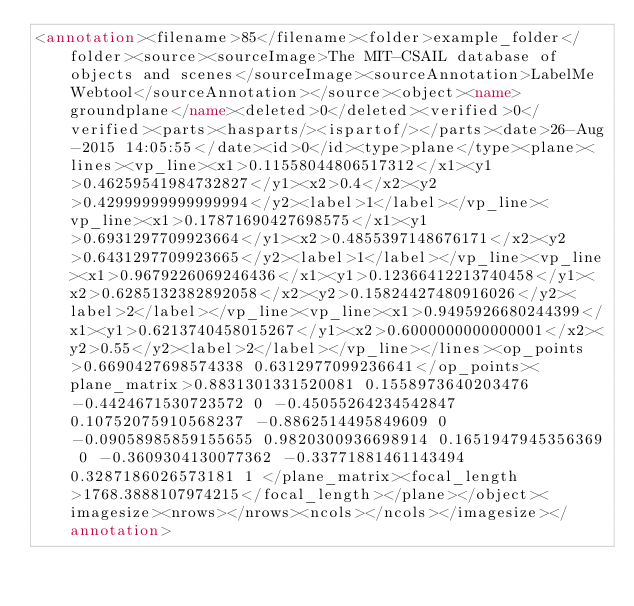<code> <loc_0><loc_0><loc_500><loc_500><_XML_><annotation><filename>85</filename><folder>example_folder</folder><source><sourceImage>The MIT-CSAIL database of objects and scenes</sourceImage><sourceAnnotation>LabelMe Webtool</sourceAnnotation></source><object><name>groundplane</name><deleted>0</deleted><verified>0</verified><parts><hasparts/><ispartof/></parts><date>26-Aug-2015 14:05:55</date><id>0</id><type>plane</type><plane><lines><vp_line><x1>0.11558044806517312</x1><y1>0.46259541984732827</y1><x2>0.4</x2><y2>0.42999999999999994</y2><label>1</label></vp_line><vp_line><x1>0.17871690427698575</x1><y1>0.6931297709923664</y1><x2>0.4855397148676171</x2><y2>0.6431297709923665</y2><label>1</label></vp_line><vp_line><x1>0.9679226069246436</x1><y1>0.12366412213740458</y1><x2>0.6285132382892058</x2><y2>0.15824427480916026</y2><label>2</label></vp_line><vp_line><x1>0.9495926680244399</x1><y1>0.6213740458015267</y1><x2>0.6000000000000001</x2><y2>0.55</y2><label>2</label></vp_line></lines><op_points>0.6690427698574338 0.6312977099236641</op_points><plane_matrix>0.8831301331520081 0.1558973640203476 -0.4424671530723572 0 -0.45055264234542847 0.10752075910568237 -0.8862514495849609 0 -0.09058985859155655 0.9820300936698914 0.1651947945356369 0 -0.3609304130077362 -0.33771881461143494 0.3287186026573181 1 </plane_matrix><focal_length>1768.3888107974215</focal_length></plane></object><imagesize><nrows></nrows><ncols></ncols></imagesize></annotation></code> 